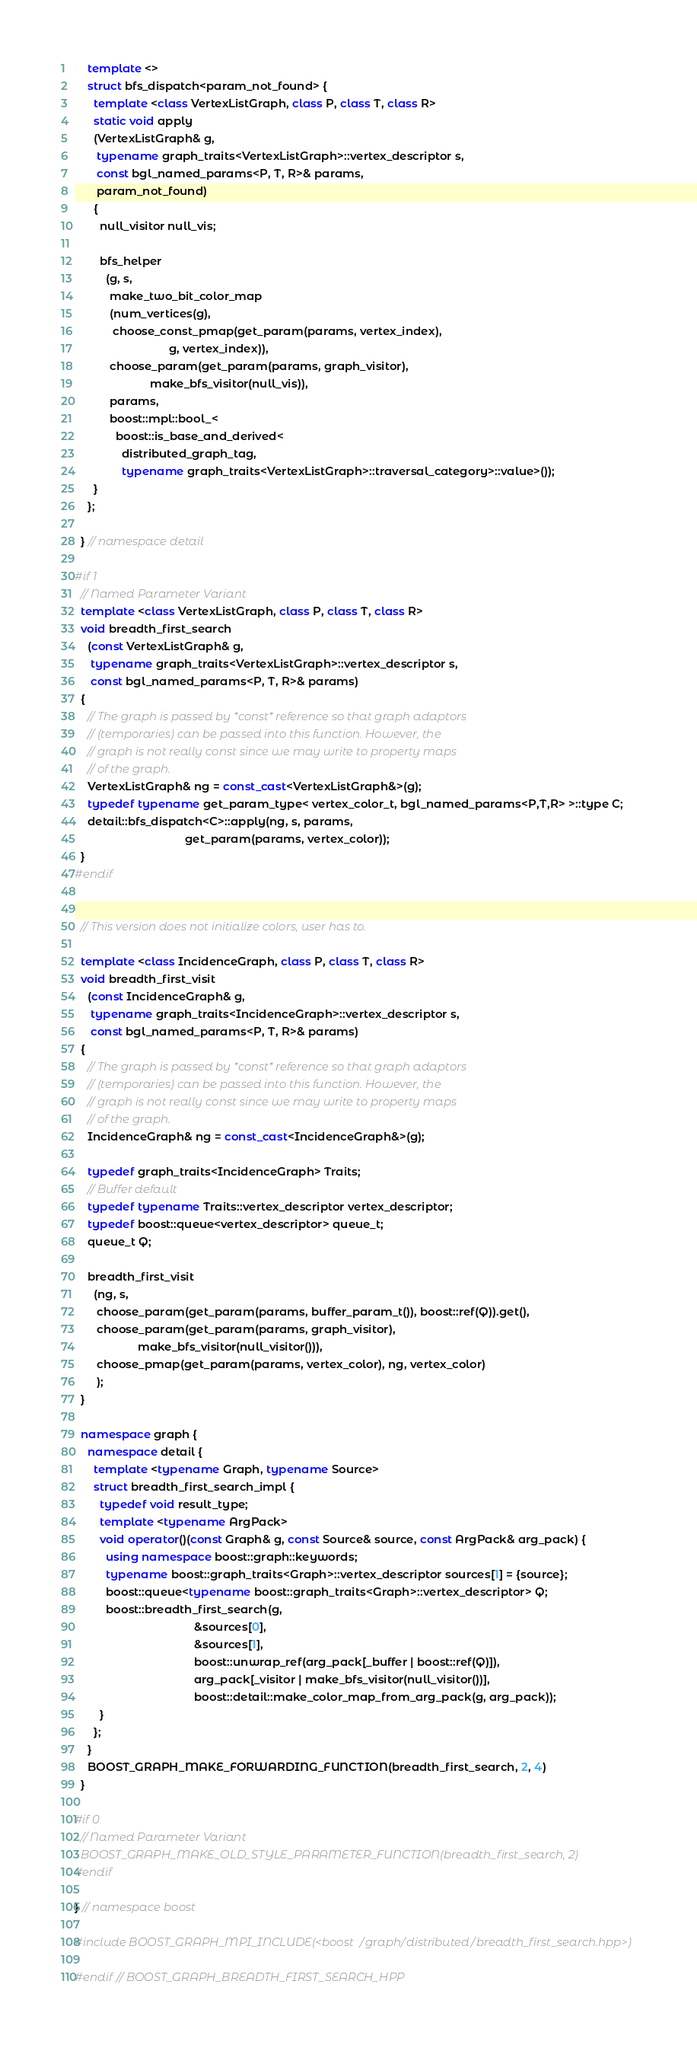Convert code to text. <code><loc_0><loc_0><loc_500><loc_500><_C++_>    template <>
    struct bfs_dispatch<param_not_found> {
      template <class VertexListGraph, class P, class T, class R>
      static void apply
      (VertexListGraph& g,
       typename graph_traits<VertexListGraph>::vertex_descriptor s,
       const bgl_named_params<P, T, R>& params,
       param_not_found)
      {
        null_visitor null_vis;

        bfs_helper
          (g, s,
           make_two_bit_color_map
           (num_vertices(g),
            choose_const_pmap(get_param(params, vertex_index),
                              g, vertex_index)),
           choose_param(get_param(params, graph_visitor),
                        make_bfs_visitor(null_vis)),
           params,
           boost::mpl::bool_<
             boost::is_base_and_derived<
               distributed_graph_tag,
               typename graph_traits<VertexListGraph>::traversal_category>::value>());
      }
    };

  } // namespace detail

#if 1
  // Named Parameter Variant
  template <class VertexListGraph, class P, class T, class R>
  void breadth_first_search
    (const VertexListGraph& g,
     typename graph_traits<VertexListGraph>::vertex_descriptor s,
     const bgl_named_params<P, T, R>& params)
  {
    // The graph is passed by *const* reference so that graph adaptors
    // (temporaries) can be passed into this function. However, the
    // graph is not really const since we may write to property maps
    // of the graph.
    VertexListGraph& ng = const_cast<VertexListGraph&>(g);
    typedef typename get_param_type< vertex_color_t, bgl_named_params<P,T,R> >::type C;
    detail::bfs_dispatch<C>::apply(ng, s, params,
                                   get_param(params, vertex_color));
  }
#endif


  // This version does not initialize colors, user has to.

  template <class IncidenceGraph, class P, class T, class R>
  void breadth_first_visit
    (const IncidenceGraph& g,
     typename graph_traits<IncidenceGraph>::vertex_descriptor s,
     const bgl_named_params<P, T, R>& params)
  {
    // The graph is passed by *const* reference so that graph adaptors
    // (temporaries) can be passed into this function. However, the
    // graph is not really const since we may write to property maps
    // of the graph.
    IncidenceGraph& ng = const_cast<IncidenceGraph&>(g);

    typedef graph_traits<IncidenceGraph> Traits;
    // Buffer default
    typedef typename Traits::vertex_descriptor vertex_descriptor;
    typedef boost::queue<vertex_descriptor> queue_t;
    queue_t Q;

    breadth_first_visit
      (ng, s,
       choose_param(get_param(params, buffer_param_t()), boost::ref(Q)).get(),
       choose_param(get_param(params, graph_visitor),
                    make_bfs_visitor(null_visitor())),
       choose_pmap(get_param(params, vertex_color), ng, vertex_color)
       );
  }

  namespace graph {
    namespace detail {
      template <typename Graph, typename Source>
      struct breadth_first_search_impl {
        typedef void result_type;
        template <typename ArgPack>
        void operator()(const Graph& g, const Source& source, const ArgPack& arg_pack) {
          using namespace boost::graph::keywords;
          typename boost::graph_traits<Graph>::vertex_descriptor sources[1] = {source};
          boost::queue<typename boost::graph_traits<Graph>::vertex_descriptor> Q;
          boost::breadth_first_search(g,
                                      &sources[0],
                                      &sources[1], 
                                      boost::unwrap_ref(arg_pack[_buffer | boost::ref(Q)]),
                                      arg_pack[_visitor | make_bfs_visitor(null_visitor())],
                                      boost::detail::make_color_map_from_arg_pack(g, arg_pack));
        }
      };
    }
    BOOST_GRAPH_MAKE_FORWARDING_FUNCTION(breadth_first_search, 2, 4)
  }

#if 0
  // Named Parameter Variant
  BOOST_GRAPH_MAKE_OLD_STYLE_PARAMETER_FUNCTION(breadth_first_search, 2)
#endif

} // namespace boost

#include BOOST_GRAPH_MPI_INCLUDE(<boost/graph/distributed/breadth_first_search.hpp>)

#endif // BOOST_GRAPH_BREADTH_FIRST_SEARCH_HPP

</code> 